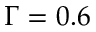<formula> <loc_0><loc_0><loc_500><loc_500>\Gamma = 0 . 6</formula> 